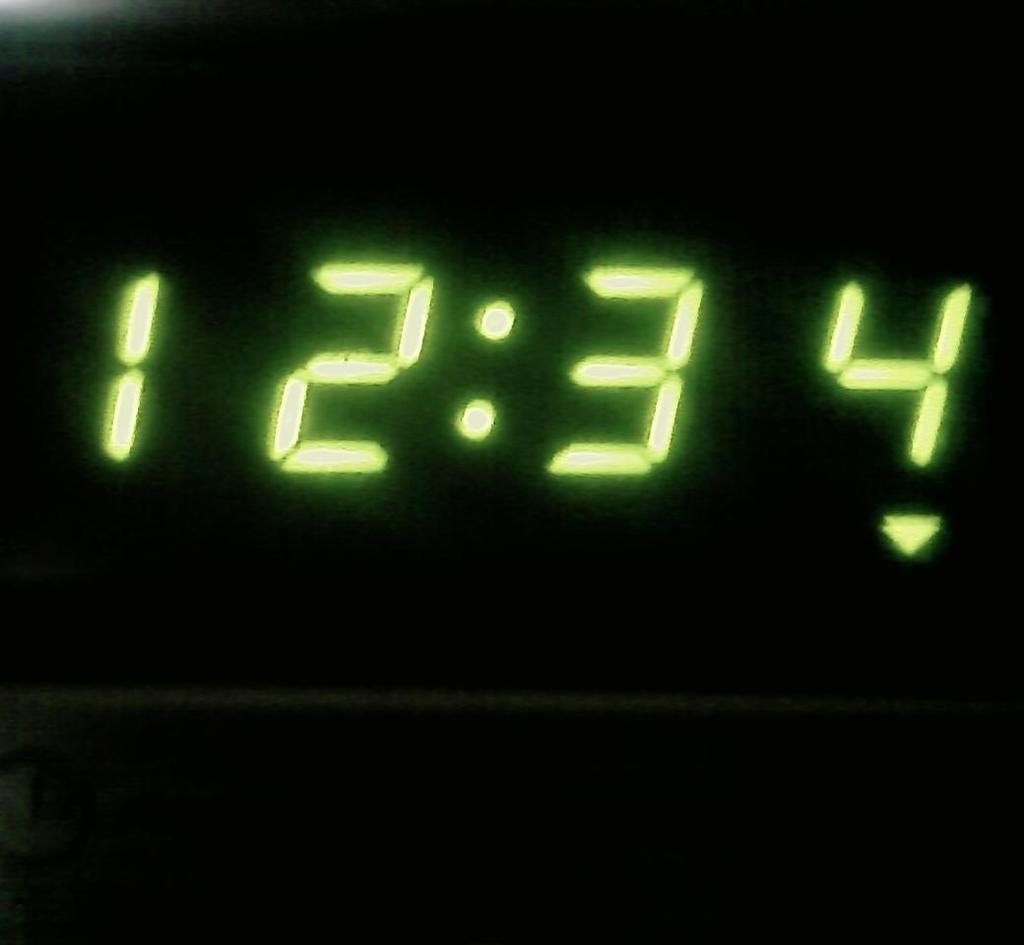<image>
Write a terse but informative summary of the picture. A clock that has 12:34 on its screen in glowing numbers. 